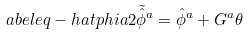<formula> <loc_0><loc_0><loc_500><loc_500>\L a b e l { e q - h a t p h i a 2 } \tilde { \hat { \phi } } ^ { a } = \hat { \phi } ^ { a } + G ^ { a } \theta</formula> 